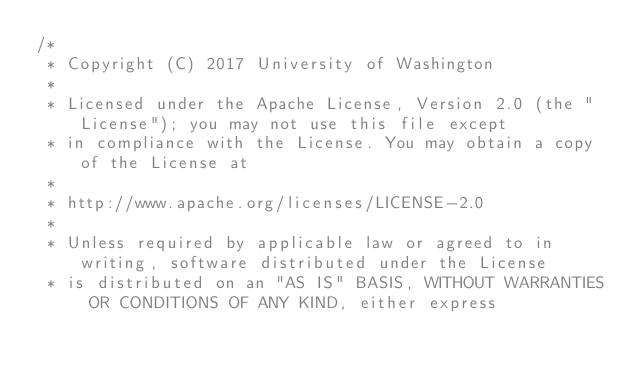Convert code to text. <code><loc_0><loc_0><loc_500><loc_500><_Java_>/*
 * Copyright (C) 2017 University of Washington
 *
 * Licensed under the Apache License, Version 2.0 (the "License"); you may not use this file except
 * in compliance with the License. You may obtain a copy of the License at
 *
 * http://www.apache.org/licenses/LICENSE-2.0
 *
 * Unless required by applicable law or agreed to in writing, software distributed under the License
 * is distributed on an "AS IS" BASIS, WITHOUT WARRANTIES OR CONDITIONS OF ANY KIND, either express</code> 